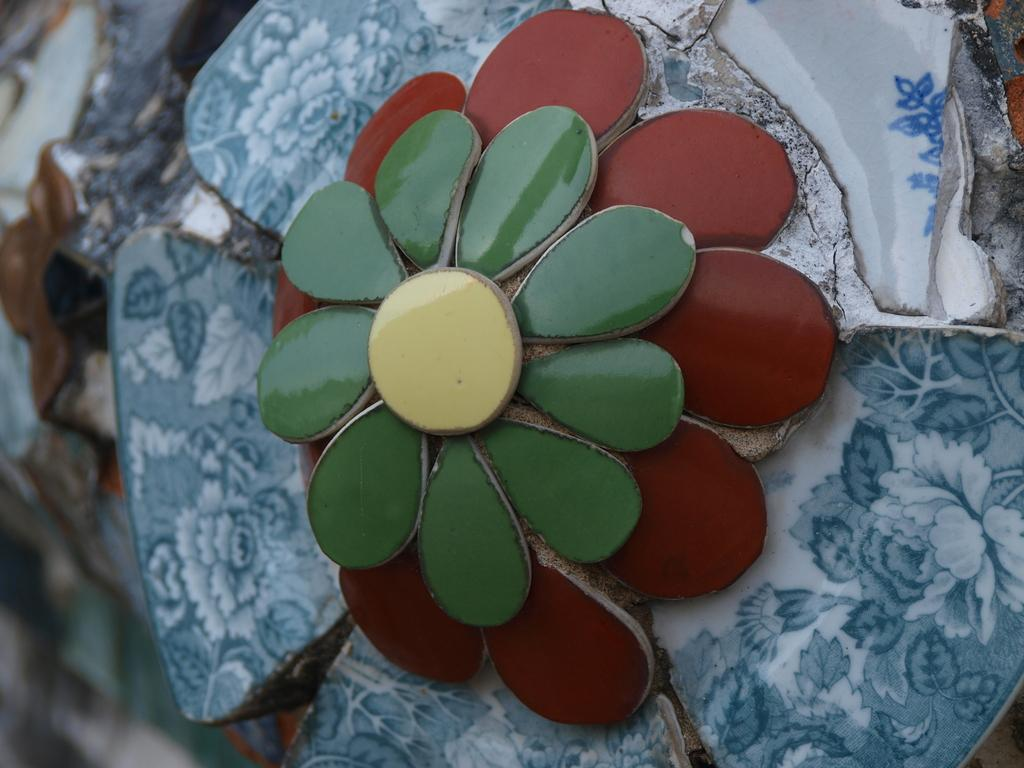What is the main subject of the image? The main subject of the image is a flower. Can you describe the design of the flower? The flower has an architectural design. What colors can be seen in the flower? The flower is in multiple colors. How many toys can be seen flying around the flower in the image? There are no toys present in the image, and therefore no such activity can be observed. 